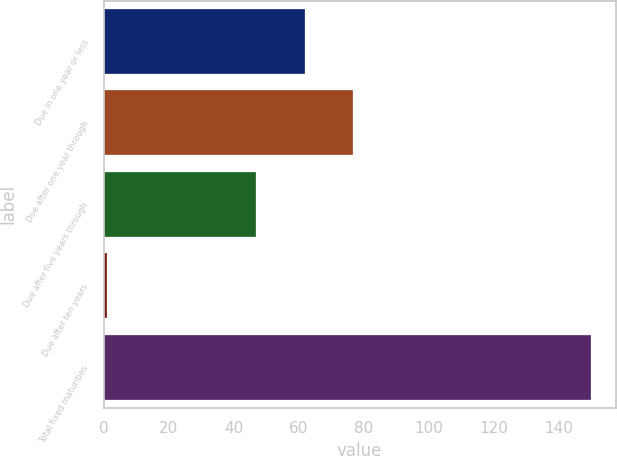Convert chart. <chart><loc_0><loc_0><loc_500><loc_500><bar_chart><fcel>Due in one year or less<fcel>Due after one year through<fcel>Due after five years through<fcel>Due after ten years<fcel>Total fixed maturities<nl><fcel>61.9<fcel>76.8<fcel>47<fcel>1<fcel>150<nl></chart> 